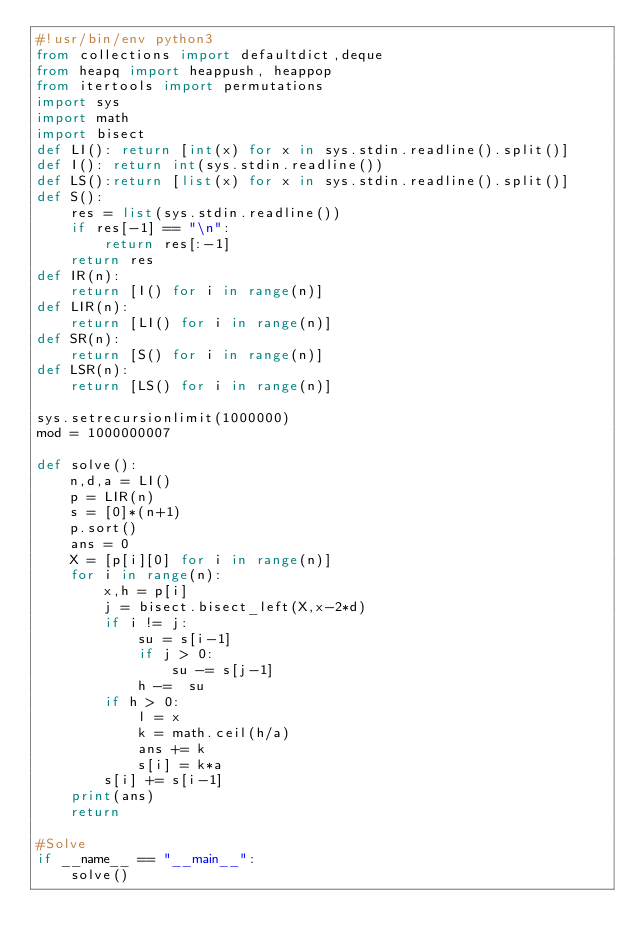Convert code to text. <code><loc_0><loc_0><loc_500><loc_500><_Python_>#!usr/bin/env python3
from collections import defaultdict,deque
from heapq import heappush, heappop
from itertools import permutations
import sys
import math
import bisect
def LI(): return [int(x) for x in sys.stdin.readline().split()]
def I(): return int(sys.stdin.readline())
def LS():return [list(x) for x in sys.stdin.readline().split()]
def S():
    res = list(sys.stdin.readline())
    if res[-1] == "\n":
        return res[:-1]
    return res
def IR(n):
    return [I() for i in range(n)]
def LIR(n):
    return [LI() for i in range(n)]
def SR(n):
    return [S() for i in range(n)]
def LSR(n):
    return [LS() for i in range(n)]

sys.setrecursionlimit(1000000)
mod = 1000000007

def solve():
    n,d,a = LI()
    p = LIR(n)
    s = [0]*(n+1)
    p.sort()
    ans = 0
    X = [p[i][0] for i in range(n)]
    for i in range(n):
        x,h = p[i]
        j = bisect.bisect_left(X,x-2*d)
        if i != j:
            su = s[i-1]
            if j > 0:
                su -= s[j-1]
            h -=  su
        if h > 0:
            l = x
            k = math.ceil(h/a)
            ans += k
            s[i] = k*a
        s[i] += s[i-1]
    print(ans)
    return

#Solve
if __name__ == "__main__":
    solve()
</code> 